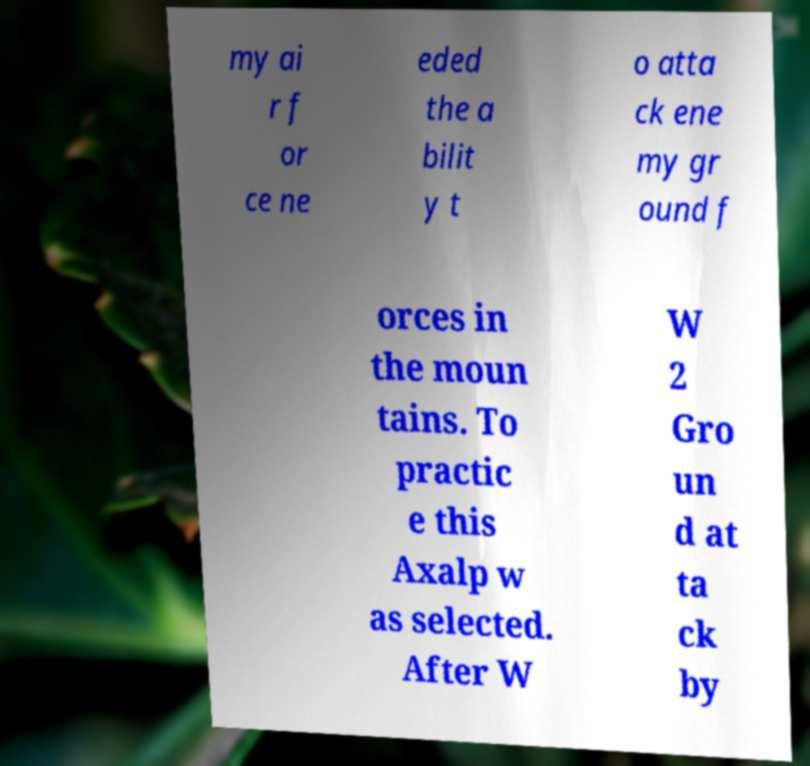Can you read and provide the text displayed in the image?This photo seems to have some interesting text. Can you extract and type it out for me? my ai r f or ce ne eded the a bilit y t o atta ck ene my gr ound f orces in the moun tains. To practic e this Axalp w as selected. After W W 2 Gro un d at ta ck by 